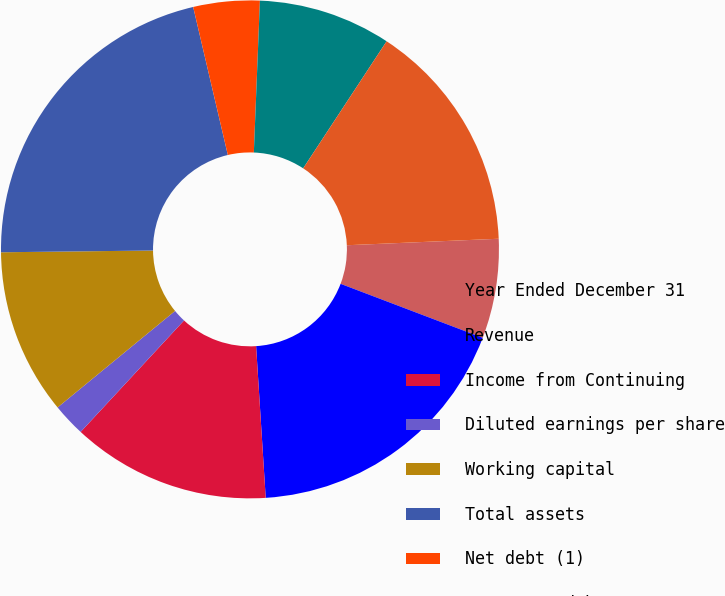<chart> <loc_0><loc_0><loc_500><loc_500><pie_chart><fcel>Year Ended December 31<fcel>Revenue<fcel>Income from Continuing<fcel>Diluted earnings per share<fcel>Working capital<fcel>Total assets<fcel>Net debt (1)<fcel>Long-term debt<fcel>Schlumberger stockholders'<fcel>Cash dividends declared per<nl><fcel>6.46%<fcel>18.21%<fcel>12.91%<fcel>2.15%<fcel>10.76%<fcel>21.52%<fcel>4.3%<fcel>8.61%<fcel>15.07%<fcel>0.0%<nl></chart> 